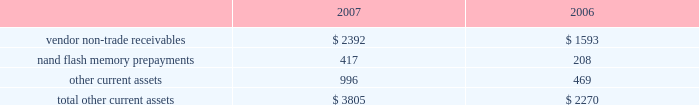Notes to consolidated financial statements ( continued ) note 2 2014financial instruments ( continued ) typically , the company hedges portions of its forecasted foreign currency exposure associated with revenue and inventory purchases over a time horizon of up to 6 months .
Derivative instruments designated as cash flow hedges must be de-designated as hedges when it is probable the forecasted hedged transaction will not occur in the initially identified time period or within a subsequent 2 month time period .
Deferred gains and losses in other comprehensive income associated with such derivative instruments are immediately reclassified into earnings in other income and expense .
Any subsequent changes in fair value of such derivative instruments are also reflected in current earnings unless they are re-designated as hedges of other transactions .
The company recognized net gains of approximately $ 672000 and $ 421000 in 2007 and 2006 , respectively , and a net loss of $ 1.6 million in 2005 in other income and expense related to the loss of hedge designation on discontinued cash flow hedges due to changes in the company 2019s forecast of future net sales and cost of sales and due to prevailing market conditions .
As of september 29 , 2007 , the company had a net deferred gain associated with cash flow hedges of approximately $ 468000 , net of taxes , substantially all of which is expected to be reclassified to earnings by the end of the second quarter of fiscal 2008 .
The net gain or loss on the effective portion of a derivative instrument designated as a net investment hedge is included in the cumulative translation adjustment account of accumulated other comprehensive income within shareholders 2019 equity .
For the years ended september 29 , 2007 and september 30 , 2006 , the company had a net loss of $ 2.6 million and a net gain of $ 7.4 million , respectively , included in the cumulative translation adjustment .
The company may also enter into foreign currency forward and option contracts to offset the foreign exchange gains and losses generated by the re-measurement of certain assets and liabilities recorded in non-functional currencies .
Changes in the fair value of these derivatives are recognized in current earnings in other income and expense as offsets to the changes in the fair value of the related assets or liabilities .
Due to currency market movements , changes in option time value can lead to increased volatility in other income and expense .
Note 3 2014consolidated financial statement details ( in millions ) other current assets .

What percentage of total other current assets in 2006 was comprised of nand flash memory prepayments? 
Computations: (208 / 2270)
Answer: 0.09163. 